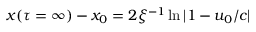<formula> <loc_0><loc_0><loc_500><loc_500>x ( \tau = \infty ) - x _ { 0 } = 2 \xi ^ { - 1 } \ln | 1 - u _ { 0 } / c |</formula> 